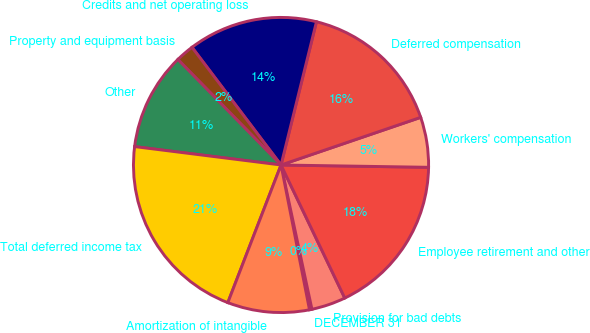Convert chart. <chart><loc_0><loc_0><loc_500><loc_500><pie_chart><fcel>DECEMBER 31<fcel>Provision for bad debts<fcel>Employee retirement and other<fcel>Workers' compensation<fcel>Deferred compensation<fcel>Credits and net operating loss<fcel>Property and equipment basis<fcel>Other<fcel>Total deferred income tax<fcel>Amortization of intangible<nl><fcel>0.27%<fcel>3.75%<fcel>17.64%<fcel>5.48%<fcel>15.91%<fcel>14.17%<fcel>2.01%<fcel>10.69%<fcel>21.12%<fcel>8.96%<nl></chart> 